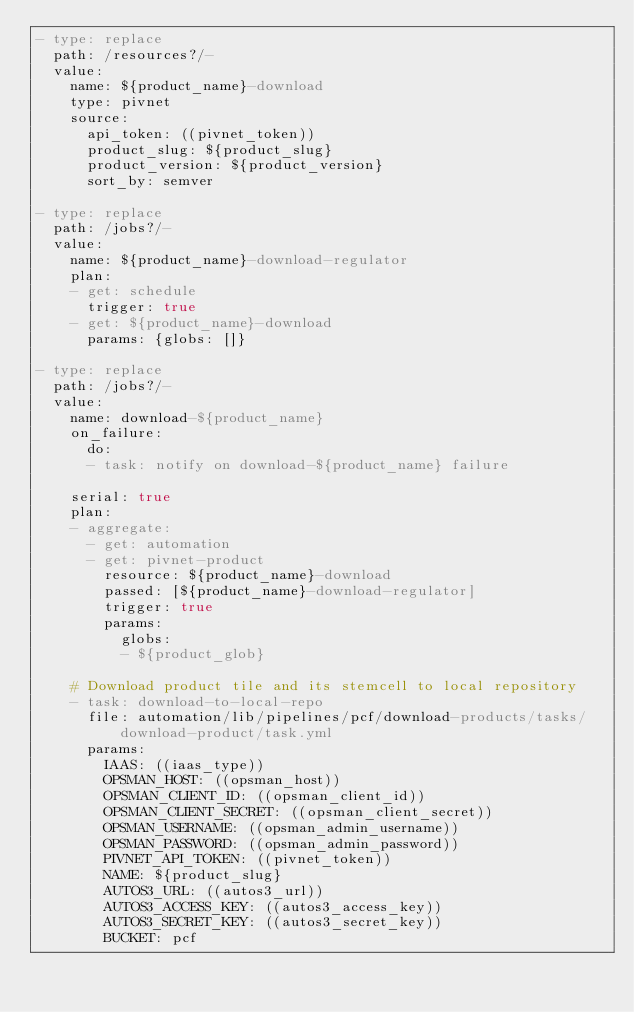Convert code to text. <code><loc_0><loc_0><loc_500><loc_500><_YAML_>- type: replace
  path: /resources?/-
  value:
    name: ${product_name}-download
    type: pivnet
    source:
      api_token: ((pivnet_token))
      product_slug: ${product_slug}
      product_version: ${product_version}
      sort_by: semver

- type: replace
  path: /jobs?/-
  value:
    name: ${product_name}-download-regulator
    plan:
    - get: schedule
      trigger: true
    - get: ${product_name}-download
      params: {globs: []}

- type: replace
  path: /jobs?/-
  value:
    name: download-${product_name}
    on_failure:
      do:
      - task: notify on download-${product_name} failure

    serial: true
    plan:
    - aggregate:
      - get: automation
      - get: pivnet-product 
        resource: ${product_name}-download
        passed: [${product_name}-download-regulator]
        trigger: true
        params:
          globs:
          - ${product_glob}

    # Download product tile and its stemcell to local repository
    - task: download-to-local-repo
      file: automation/lib/pipelines/pcf/download-products/tasks/download-product/task.yml
      params:
        IAAS: ((iaas_type))
        OPSMAN_HOST: ((opsman_host))
        OPSMAN_CLIENT_ID: ((opsman_client_id))
        OPSMAN_CLIENT_SECRET: ((opsman_client_secret))
        OPSMAN_USERNAME: ((opsman_admin_username))
        OPSMAN_PASSWORD: ((opsman_admin_password))
        PIVNET_API_TOKEN: ((pivnet_token))
        NAME: ${product_slug}
        AUTOS3_URL: ((autos3_url))
        AUTOS3_ACCESS_KEY: ((autos3_access_key))
        AUTOS3_SECRET_KEY: ((autos3_secret_key))
        BUCKET: pcf
</code> 